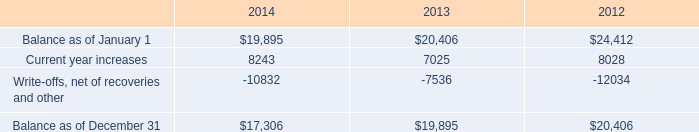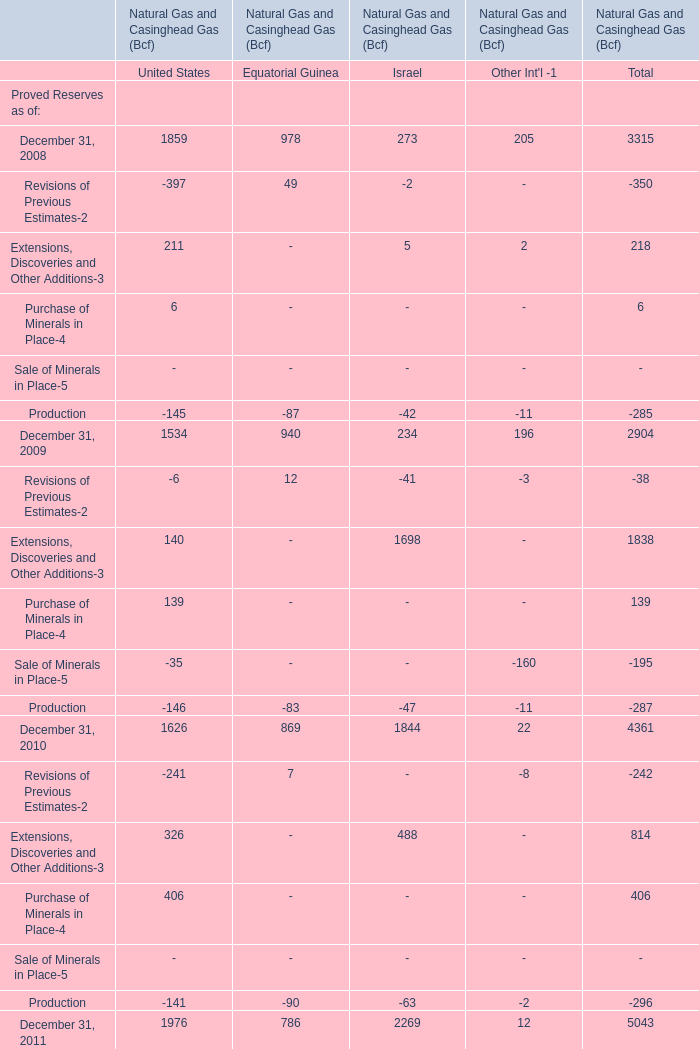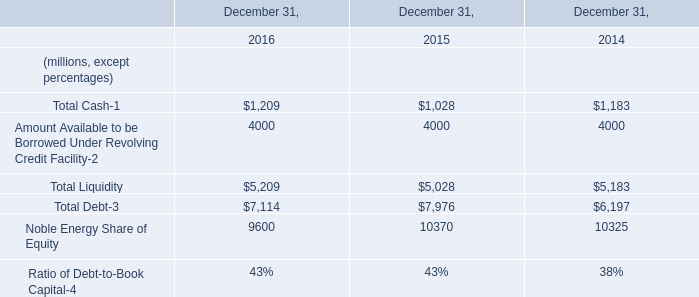How many Proved Reserves exceed the average of Proved Reserves in 2008 for Total? 
Answer: 1. 